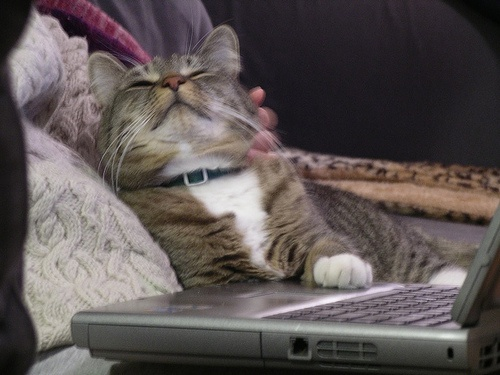Describe the objects in this image and their specific colors. I can see cat in black, gray, and darkgray tones, couch in black and gray tones, laptop in black, gray, and darkgray tones, and people in black and gray tones in this image. 